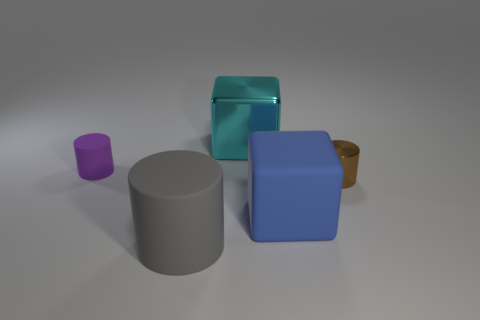Add 5 small yellow cubes. How many objects exist? 10 Subtract all cylinders. How many objects are left? 2 Subtract all brown metal cylinders. Subtract all tiny purple matte cylinders. How many objects are left? 3 Add 5 cyan metallic blocks. How many cyan metallic blocks are left? 6 Add 2 yellow blocks. How many yellow blocks exist? 2 Subtract 0 blue cylinders. How many objects are left? 5 